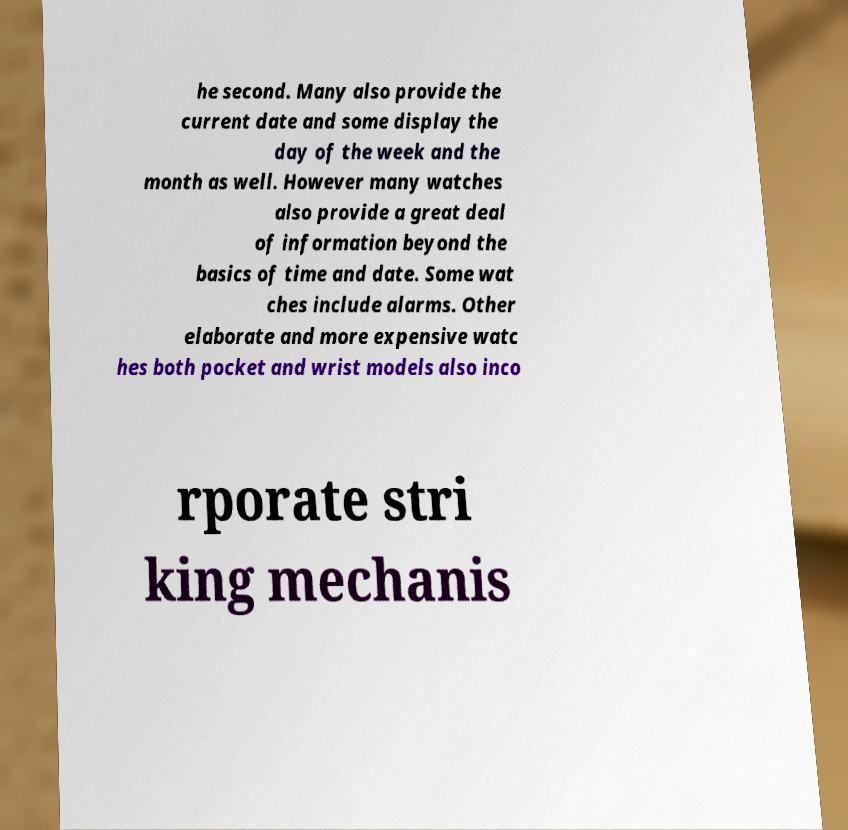Please identify and transcribe the text found in this image. he second. Many also provide the current date and some display the day of the week and the month as well. However many watches also provide a great deal of information beyond the basics of time and date. Some wat ches include alarms. Other elaborate and more expensive watc hes both pocket and wrist models also inco rporate stri king mechanis 